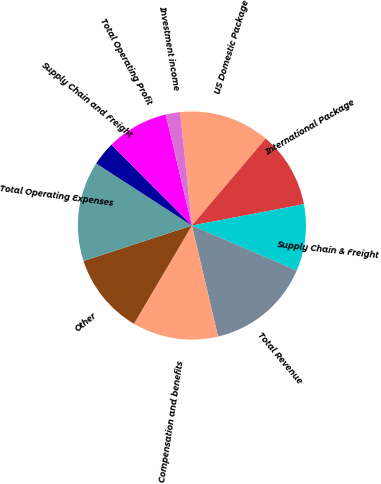Convert chart. <chart><loc_0><loc_0><loc_500><loc_500><pie_chart><fcel>US Domestic Package<fcel>International Package<fcel>Supply Chain & Freight<fcel>Total Revenue<fcel>Compensation and benefits<fcel>Other<fcel>Total Operating Expenses<fcel>Supply Chain and Freight<fcel>Total Operating Profit<fcel>Investment income<nl><fcel>12.84%<fcel>10.81%<fcel>9.46%<fcel>14.86%<fcel>12.16%<fcel>11.49%<fcel>14.19%<fcel>3.38%<fcel>8.78%<fcel>2.03%<nl></chart> 